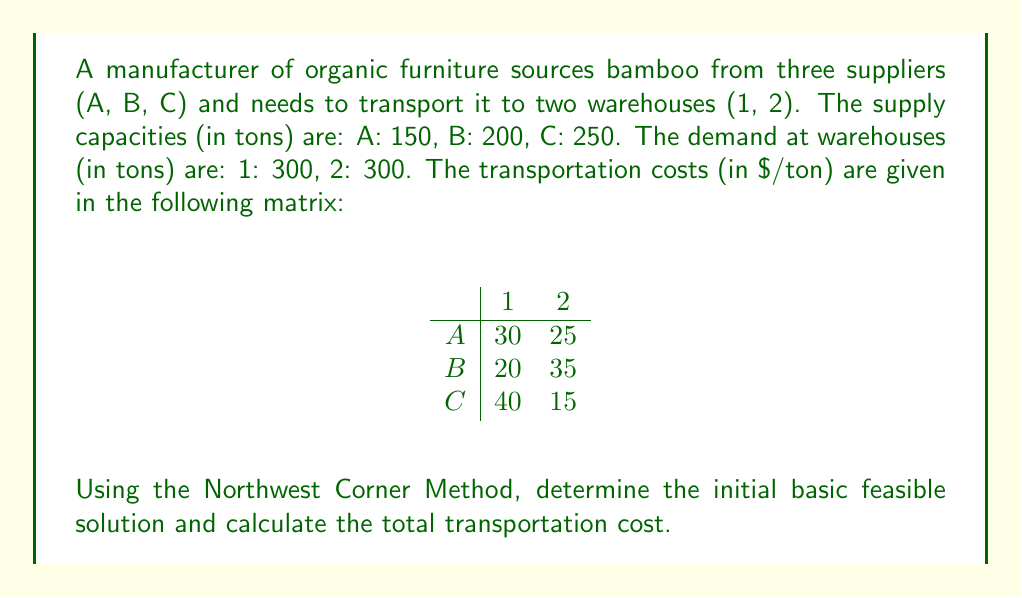Help me with this question. To solve this transportation problem using the Northwest Corner Method:

1. Start with the upper-left corner (Northwest) of the transportation matrix.

2. Allocate the maximum possible amount based on supply and demand constraints.

3. Cross out the satisfied row or column and move to the next available cell.

4. Repeat until all supplies and demands are satisfied.

Step-by-step allocation:

a) A1: Allocate min(150, 300) = 150
   Remaining: A: 0, B: 200, C: 250; 1: 150, 2: 300

b) B1: Allocate min(200, 150) = 150
   Remaining: A: 0, B: 50, C: 250; 1: 0, 2: 300

c) B2: Allocate min(50, 300) = 50
   Remaining: A: 0, B: 0, C: 250; 1: 0, 2: 250

d) C2: Allocate min(250, 250) = 250
   All supplies and demands are satisfied.

The initial basic feasible solution is:
$$
\begin{array}{c|cc}
 & 1 & 2 \\
\hline
A & 150 & 0 \\
B & 150 & 50 \\
C & 0 & 250
\end{array}
$$

To calculate the total transportation cost:

$$ \text{Total Cost} = 150 \times 30 + 150 \times 20 + 50 \times 35 + 250 \times 15 $$
$$ = 4500 + 3000 + 1750 + 3750 $$
$$ = 13000 $$
Answer: The initial basic feasible solution using the Northwest Corner Method is:
$$
\begin{array}{c|cc}
 & 1 & 2 \\
\hline
A & 150 & 0 \\
B & 150 & 50 \\
C & 0 & 250
\end{array}
$$
The total transportation cost is $13,000. 